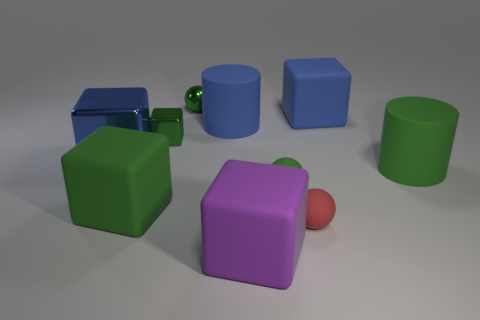Is the purple block made of the same material as the green ball behind the small green rubber thing?
Give a very brief answer. No. What is the shape of the large green matte object to the left of the big green rubber cylinder?
Your answer should be compact. Cube. What number of other objects are there of the same material as the small red sphere?
Provide a succinct answer. 6. The red rubber sphere has what size?
Offer a terse response. Small. What number of other objects are there of the same color as the big metallic object?
Offer a terse response. 2. The matte cube that is left of the tiny green rubber ball and behind the tiny red object is what color?
Your response must be concise. Green. What number of red objects are there?
Your response must be concise. 1. Is the material of the red object the same as the green cylinder?
Give a very brief answer. Yes. There is a big green matte object that is right of the purple rubber object that is in front of the rubber cube that is behind the blue cylinder; what is its shape?
Offer a terse response. Cylinder. Is the big blue cube to the right of the purple rubber thing made of the same material as the small green sphere that is on the right side of the purple rubber cube?
Your answer should be very brief. Yes. 